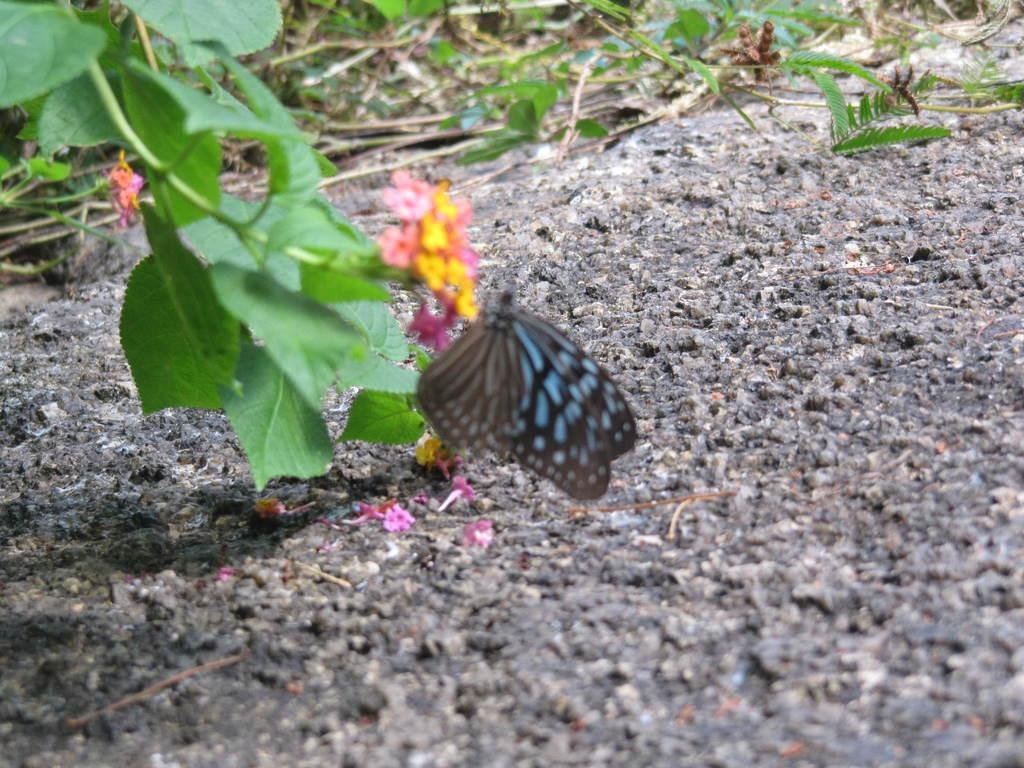What is the main subject of the image? There is a butterfly in the image. Where is the butterfly located? The butterfly is on the flowers of a plant. What other parts of the plant can be seen in the image? There are leaves visible in the image. What else is present on the ground in the image? There are flowers on the ground in the image. What type of lace can be seen on the butterfly's wings in the image? There is no lace present on the butterfly's wings in the image; the wings are natural and do not have any man-made materials attached to them. 